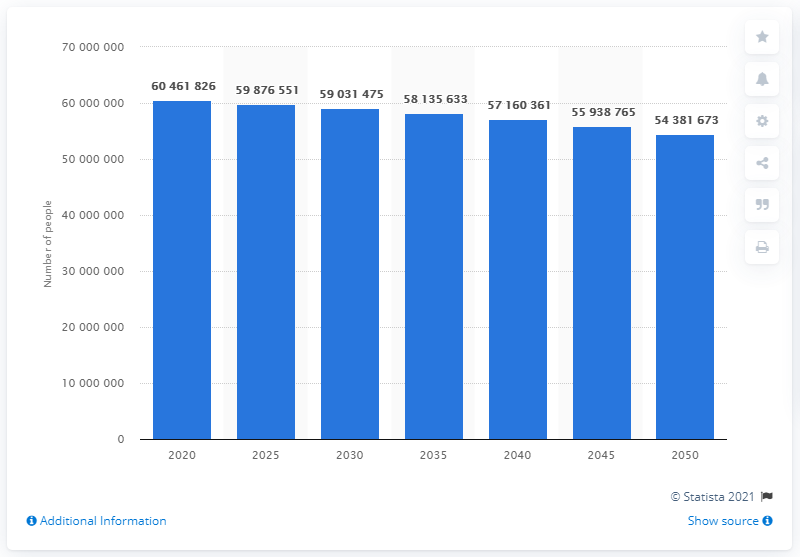Give some essential details in this illustration. As of January 2020, the Italian population was approximately 59,876,551 people. In 20 years, the number of Italians is expected to be approximately 543,816,730. In 2020, projections were made indicating that the population in Italy would decrease in the following years. 